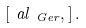Convert formula to latex. <formula><loc_0><loc_0><loc_500><loc_500>[ \ a l _ { \ G e r } , ] \, .</formula> 